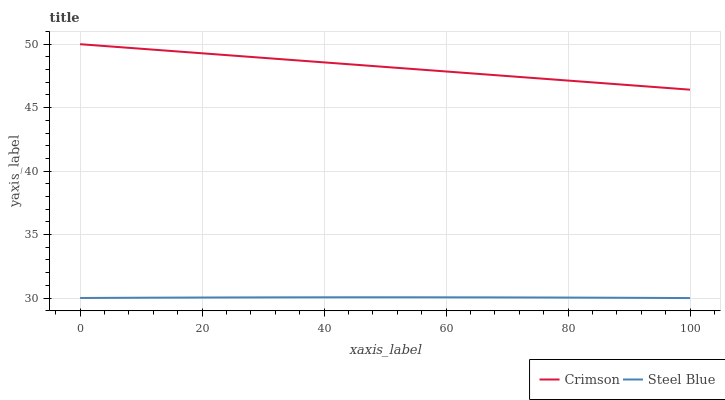Does Steel Blue have the minimum area under the curve?
Answer yes or no. Yes. Does Crimson have the maximum area under the curve?
Answer yes or no. Yes. Does Steel Blue have the maximum area under the curve?
Answer yes or no. No. Is Crimson the smoothest?
Answer yes or no. Yes. Is Steel Blue the roughest?
Answer yes or no. Yes. Is Steel Blue the smoothest?
Answer yes or no. No. Does Steel Blue have the lowest value?
Answer yes or no. Yes. Does Crimson have the highest value?
Answer yes or no. Yes. Does Steel Blue have the highest value?
Answer yes or no. No. Is Steel Blue less than Crimson?
Answer yes or no. Yes. Is Crimson greater than Steel Blue?
Answer yes or no. Yes. Does Steel Blue intersect Crimson?
Answer yes or no. No. 